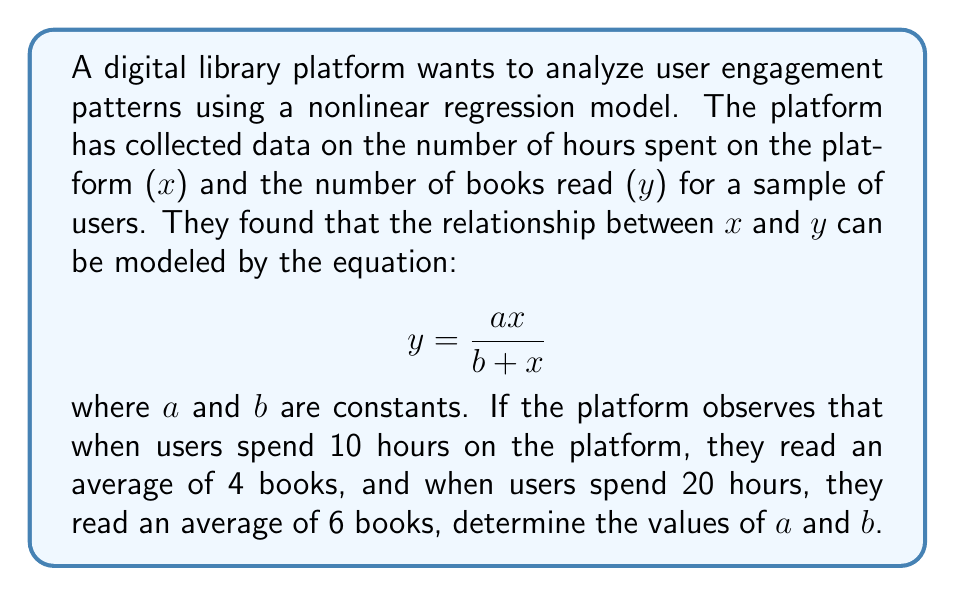Show me your answer to this math problem. To solve this problem, we'll use the given equation and the two data points to create a system of equations:

1) For x = 10 and y = 4:
   $$ 4 = \frac{a(10)}{b + 10} $$

2) For x = 20 and y = 6:
   $$ 6 = \frac{a(20)}{b + 20} $$

3) Simplify the first equation:
   $$ 4 = \frac{10a}{b + 10} $$
   $$ 4b + 40 = 10a $$

4) Simplify the second equation:
   $$ 6 = \frac{20a}{b + 20} $$
   $$ 6b + 120 = 20a $$

5) From step 3, we can express a in terms of b:
   $$ a = \frac{4b + 40}{10} $$

6) Substitute this into the equation from step 4:
   $$ 6b + 120 = 20(\frac{4b + 40}{10}) $$
   $$ 6b + 120 = 8b + 80 $$
   $$ 40 = 2b $$
   $$ b = 20 $$

7) Now that we know b, we can find a:
   $$ a = \frac{4(20) + 40}{10} = \frac{120}{10} = 12 $$

Therefore, the constants in the nonlinear regression model are a = 12 and b = 20.
Answer: a = 12, b = 20 